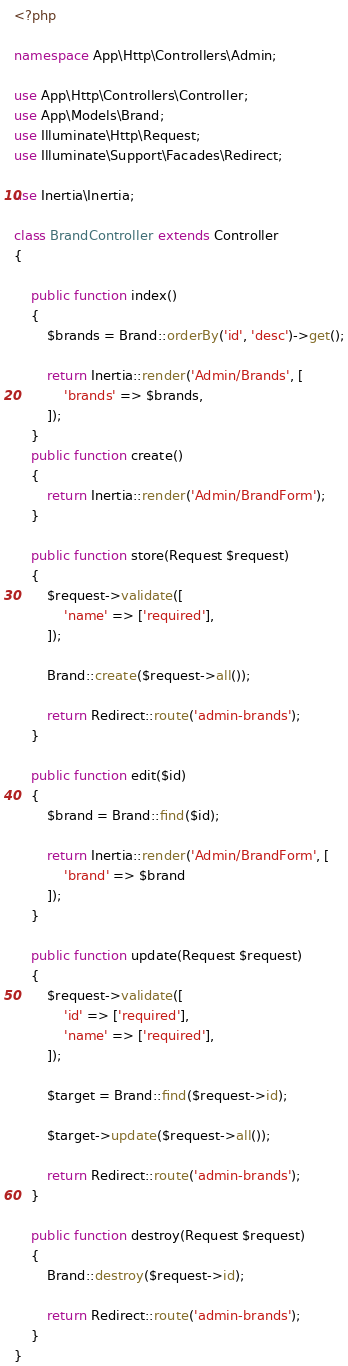Convert code to text. <code><loc_0><loc_0><loc_500><loc_500><_PHP_><?php

namespace App\Http\Controllers\Admin;

use App\Http\Controllers\Controller;
use App\Models\Brand;
use Illuminate\Http\Request;
use Illuminate\Support\Facades\Redirect;

use Inertia\Inertia;

class BrandController extends Controller
{

    public function index()
    {
        $brands = Brand::orderBy('id', 'desc')->get();

        return Inertia::render('Admin/Brands', [
            'brands' => $brands,
        ]);
    }
    public function create()
    {
        return Inertia::render('Admin/BrandForm');
    }

    public function store(Request $request)
    {
        $request->validate([
            'name' => ['required'],
        ]);

        Brand::create($request->all());

        return Redirect::route('admin-brands');
    }

    public function edit($id)
    {
        $brand = Brand::find($id);

        return Inertia::render('Admin/BrandForm', [
            'brand' => $brand
        ]);
    }

    public function update(Request $request)
    {
        $request->validate([
            'id' => ['required'],
            'name' => ['required'],
        ]);

        $target = Brand::find($request->id);

        $target->update($request->all());

        return Redirect::route('admin-brands');
    }

    public function destroy(Request $request)
    {
        Brand::destroy($request->id);

        return Redirect::route('admin-brands');
    }
}
</code> 